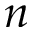Convert formula to latex. <formula><loc_0><loc_0><loc_500><loc_500>n</formula> 